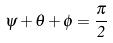Convert formula to latex. <formula><loc_0><loc_0><loc_500><loc_500>\psi + \theta + \phi = \frac { \pi } { 2 }</formula> 